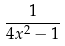<formula> <loc_0><loc_0><loc_500><loc_500>\frac { 1 } { 4 x ^ { 2 } - 1 }</formula> 